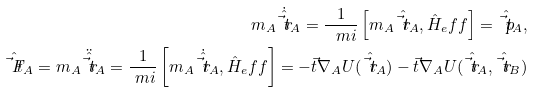<formula> <loc_0><loc_0><loc_500><loc_500>m _ { A } \dot { \hat { \vec { t } { r } } } _ { A } = \frac { 1 } { \ m i } \left [ m _ { A } \hat { \vec { t } { r } } _ { A } , \hat { H } _ { e } f f \right ] = \hat { \vec { t } { p } } _ { A } , \\ \hat { \vec { t } { F } } _ { A } = m _ { A } \ddot { \hat { \vec { t } { r } } } _ { A } = \frac { 1 } { \ m i } \left [ m _ { A } \dot { \hat { \vec { t } { r } } } _ { A } , \hat { H } _ { e } f f \right ] = - \vec { t } { \nabla } _ { A } U ( \hat { \vec { t } { r } } _ { A } ) - \vec { t } { \nabla } _ { A } U ( \hat { \vec { t } { r } } _ { A } , \hat { \vec { t } { r } } _ { B } )</formula> 